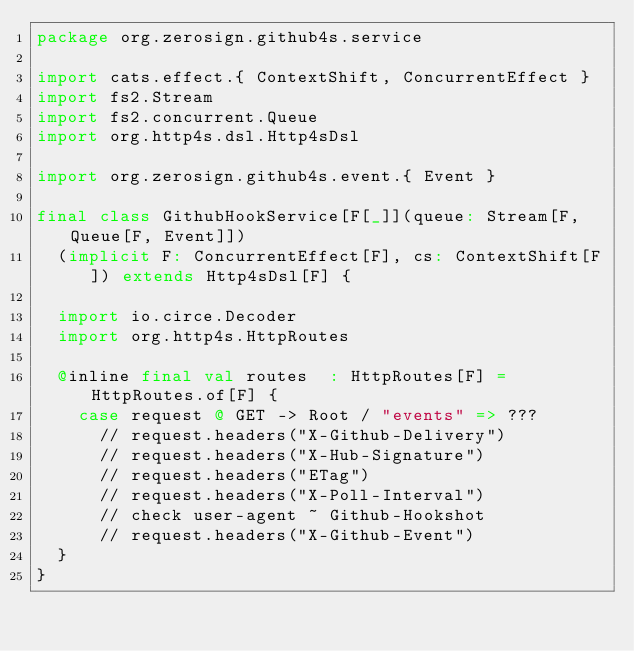Convert code to text. <code><loc_0><loc_0><loc_500><loc_500><_Scala_>package org.zerosign.github4s.service

import cats.effect.{ ContextShift, ConcurrentEffect }
import fs2.Stream
import fs2.concurrent.Queue
import org.http4s.dsl.Http4sDsl

import org.zerosign.github4s.event.{ Event }

final class GithubHookService[F[_]](queue: Stream[F, Queue[F, Event]])
  (implicit F: ConcurrentEffect[F], cs: ContextShift[F]) extends Http4sDsl[F] {

  import io.circe.Decoder
  import org.http4s.HttpRoutes

  @inline final val routes  : HttpRoutes[F] = HttpRoutes.of[F] {
    case request @ GET -> Root / "events" => ???
      // request.headers("X-Github-Delivery")
      // request.headers("X-Hub-Signature")
      // request.headers("ETag")
      // request.headers("X-Poll-Interval")
      // check user-agent ~ Github-Hookshot
      // request.headers("X-Github-Event")
  }
}
</code> 